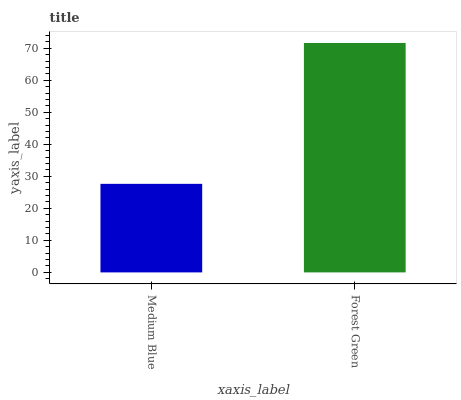Is Medium Blue the minimum?
Answer yes or no. Yes. Is Forest Green the maximum?
Answer yes or no. Yes. Is Forest Green the minimum?
Answer yes or no. No. Is Forest Green greater than Medium Blue?
Answer yes or no. Yes. Is Medium Blue less than Forest Green?
Answer yes or no. Yes. Is Medium Blue greater than Forest Green?
Answer yes or no. No. Is Forest Green less than Medium Blue?
Answer yes or no. No. Is Forest Green the high median?
Answer yes or no. Yes. Is Medium Blue the low median?
Answer yes or no. Yes. Is Medium Blue the high median?
Answer yes or no. No. Is Forest Green the low median?
Answer yes or no. No. 